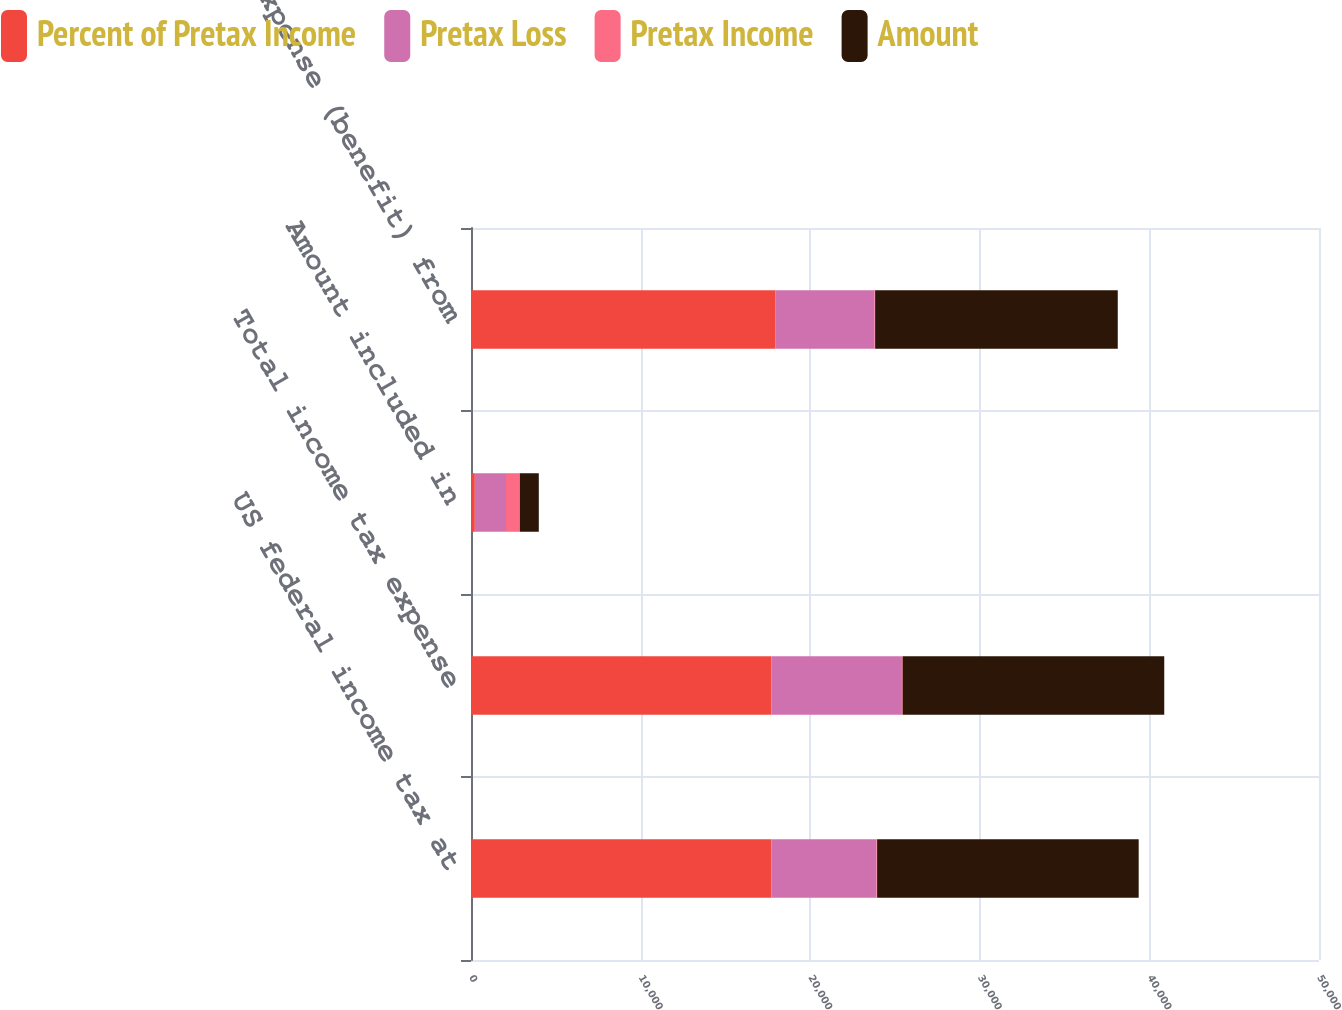Convert chart to OTSL. <chart><loc_0><loc_0><loc_500><loc_500><stacked_bar_chart><ecel><fcel>US federal income tax at<fcel>Total income tax expense<fcel>Amount included in<fcel>Tax expense (benefit) from<nl><fcel>Percent of Pretax Income<fcel>17711<fcel>17711<fcel>225<fcel>17936<nl><fcel>Pretax Loss<fcel>6199<fcel>7698<fcel>1839<fcel>5859<nl><fcel>Pretax Income<fcel>35<fcel>43.5<fcel>817.3<fcel>32.7<nl><fcel>Amount<fcel>15423<fcel>15423<fcel>1116<fcel>14307<nl></chart> 